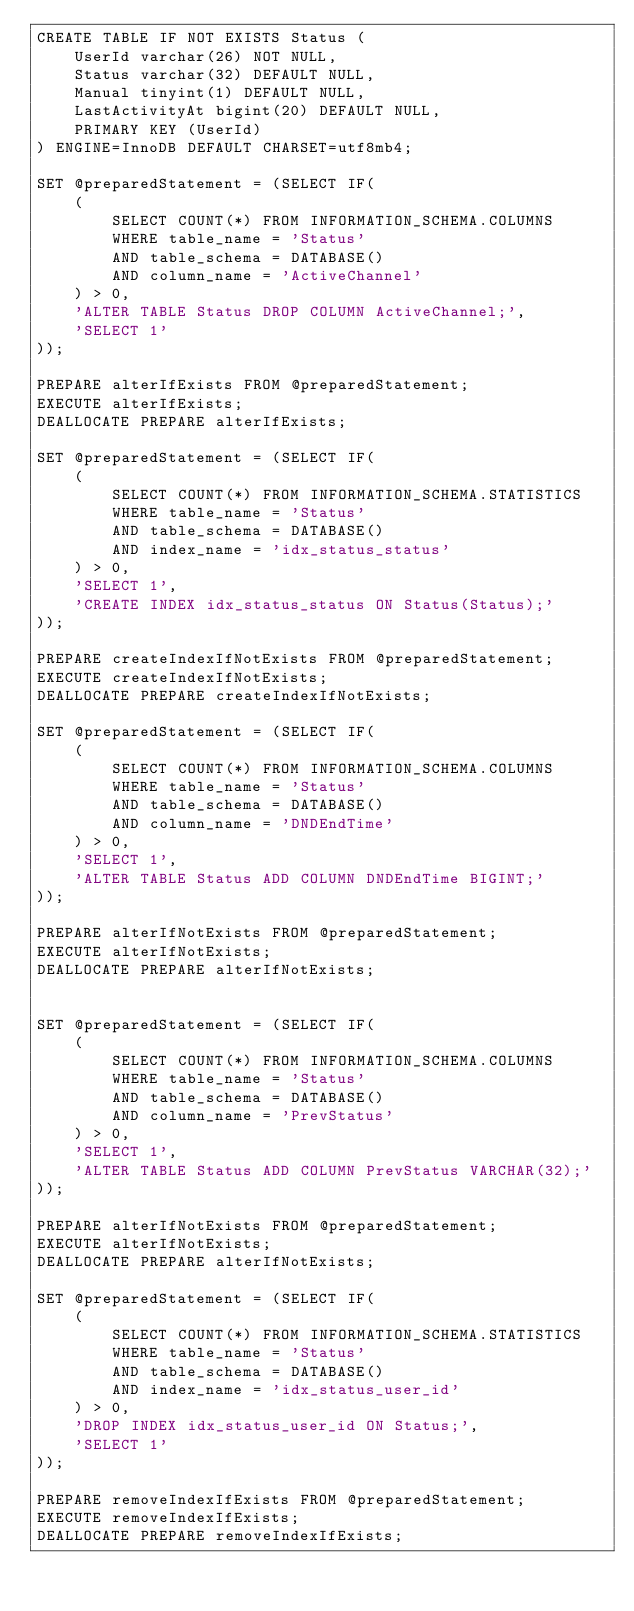<code> <loc_0><loc_0><loc_500><loc_500><_SQL_>CREATE TABLE IF NOT EXISTS Status (
    UserId varchar(26) NOT NULL,
    Status varchar(32) DEFAULT NULL,
    Manual tinyint(1) DEFAULT NULL,
    LastActivityAt bigint(20) DEFAULT NULL,
    PRIMARY KEY (UserId)
) ENGINE=InnoDB DEFAULT CHARSET=utf8mb4;

SET @preparedStatement = (SELECT IF(
    (
        SELECT COUNT(*) FROM INFORMATION_SCHEMA.COLUMNS
        WHERE table_name = 'Status'
        AND table_schema = DATABASE()
        AND column_name = 'ActiveChannel'
    ) > 0,
    'ALTER TABLE Status DROP COLUMN ActiveChannel;',
    'SELECT 1'
));

PREPARE alterIfExists FROM @preparedStatement;
EXECUTE alterIfExists;
DEALLOCATE PREPARE alterIfExists;

SET @preparedStatement = (SELECT IF(
    (
        SELECT COUNT(*) FROM INFORMATION_SCHEMA.STATISTICS
        WHERE table_name = 'Status'
        AND table_schema = DATABASE()
        AND index_name = 'idx_status_status'
    ) > 0,
    'SELECT 1',
    'CREATE INDEX idx_status_status ON Status(Status);'
));

PREPARE createIndexIfNotExists FROM @preparedStatement;
EXECUTE createIndexIfNotExists;
DEALLOCATE PREPARE createIndexIfNotExists;

SET @preparedStatement = (SELECT IF(
    (
        SELECT COUNT(*) FROM INFORMATION_SCHEMA.COLUMNS
        WHERE table_name = 'Status'
        AND table_schema = DATABASE()
        AND column_name = 'DNDEndTime'
    ) > 0,
    'SELECT 1',
    'ALTER TABLE Status ADD COLUMN DNDEndTime BIGINT;'
));

PREPARE alterIfNotExists FROM @preparedStatement;
EXECUTE alterIfNotExists;
DEALLOCATE PREPARE alterIfNotExists;


SET @preparedStatement = (SELECT IF(
    (
        SELECT COUNT(*) FROM INFORMATION_SCHEMA.COLUMNS
        WHERE table_name = 'Status'
        AND table_schema = DATABASE()
        AND column_name = 'PrevStatus'
    ) > 0,
    'SELECT 1',
    'ALTER TABLE Status ADD COLUMN PrevStatus VARCHAR(32);'
));

PREPARE alterIfNotExists FROM @preparedStatement;
EXECUTE alterIfNotExists;
DEALLOCATE PREPARE alterIfNotExists;

SET @preparedStatement = (SELECT IF(
    (
        SELECT COUNT(*) FROM INFORMATION_SCHEMA.STATISTICS
        WHERE table_name = 'Status'
        AND table_schema = DATABASE()
        AND index_name = 'idx_status_user_id'
    ) > 0,
    'DROP INDEX idx_status_user_id ON Status;',
    'SELECT 1'
));

PREPARE removeIndexIfExists FROM @preparedStatement;
EXECUTE removeIndexIfExists;
DEALLOCATE PREPARE removeIndexIfExists;
</code> 